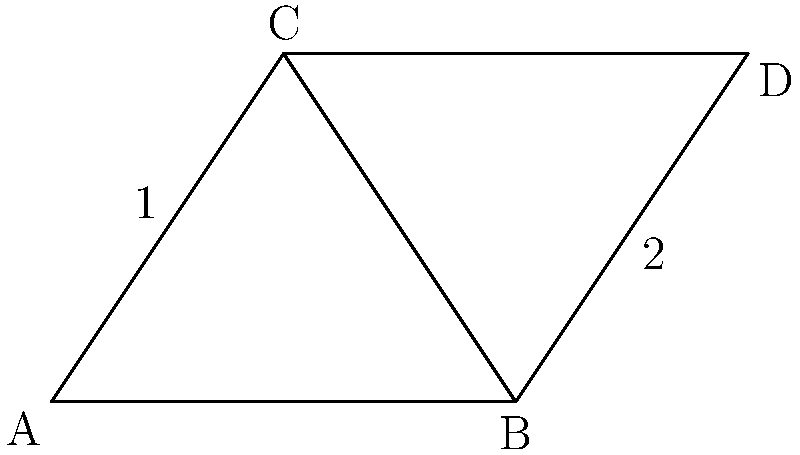In this ancient Egyptian pyramid design, two triangles are formed by the structure's outline. Given that $\overline{BC}$ is a common side and $\overline{AB} \cong \overline{CD}$, which criterion can be used to prove that triangle ABC is congruent to triangle BCD? To prove that triangle ABC is congruent to triangle BCD, we need to follow these steps:

1. Identify the given information:
   - $\overline{BC}$ is a common side to both triangles
   - $\overline{AB} \cong \overline{CD}$ (given in the question)

2. Analyze the triangles:
   - Triangle ABC shares side $\overline{BC}$ with triangle BCD
   - $\overline{AB}$ in triangle ABC corresponds to $\overline{CD}$ in triangle BCD

3. Recall the congruence criteria:
   - SSS (Side-Side-Side)
   - SAS (Side-Angle-Side)
   - ASA (Angle-Side-Angle)
   - AAS (Angle-Angle-Side)

4. Apply the appropriate criterion:
   - We have two pairs of corresponding sides: $\overline{BC}$ (common) and $\overline{AB} \cong \overline{CD}$
   - The included angle between these sides is the same for both triangles (angle B)

5. Conclude:
   - This scenario matches the SAS (Side-Angle-Side) criterion for triangle congruence

Therefore, we can use the SAS (Side-Angle-Side) criterion to prove that triangle ABC is congruent to triangle BCD.
Answer: SAS (Side-Angle-Side) 